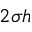<formula> <loc_0><loc_0><loc_500><loc_500>2 \sigma h</formula> 